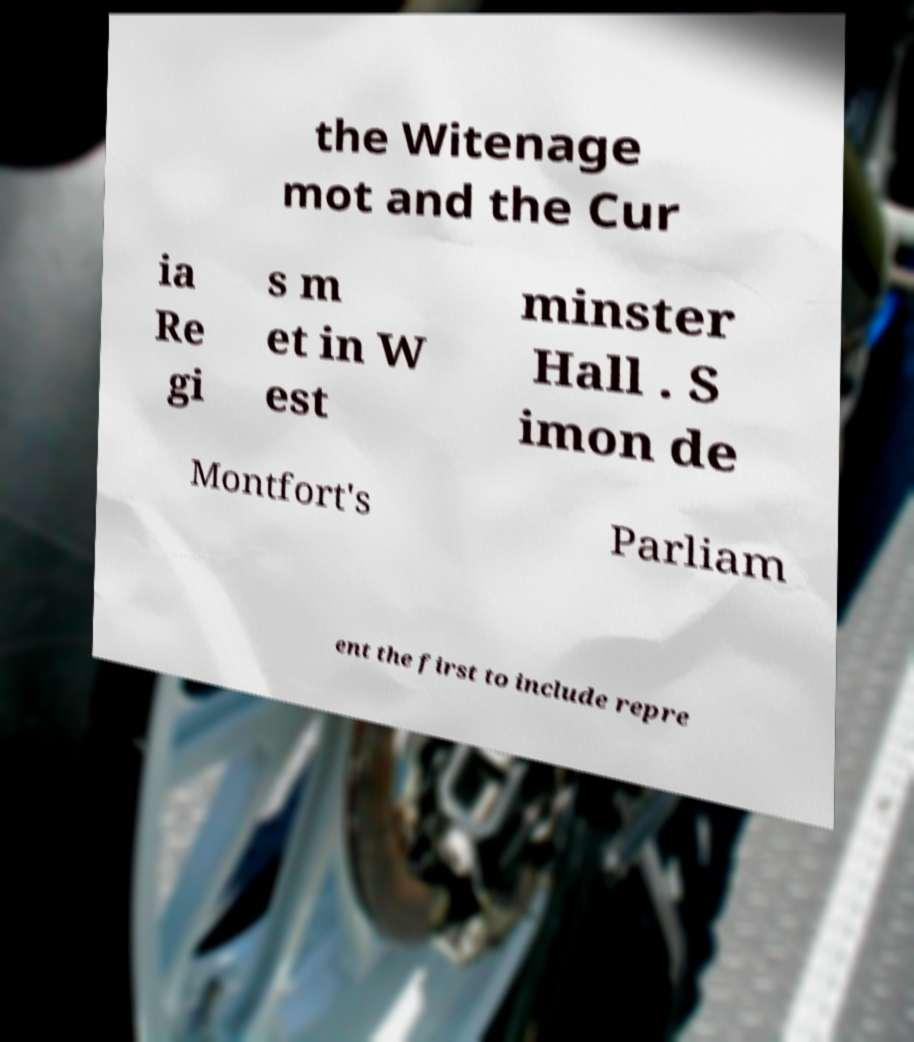Please read and relay the text visible in this image. What does it say? the Witenage mot and the Cur ia Re gi s m et in W est minster Hall . S imon de Montfort's Parliam ent the first to include repre 